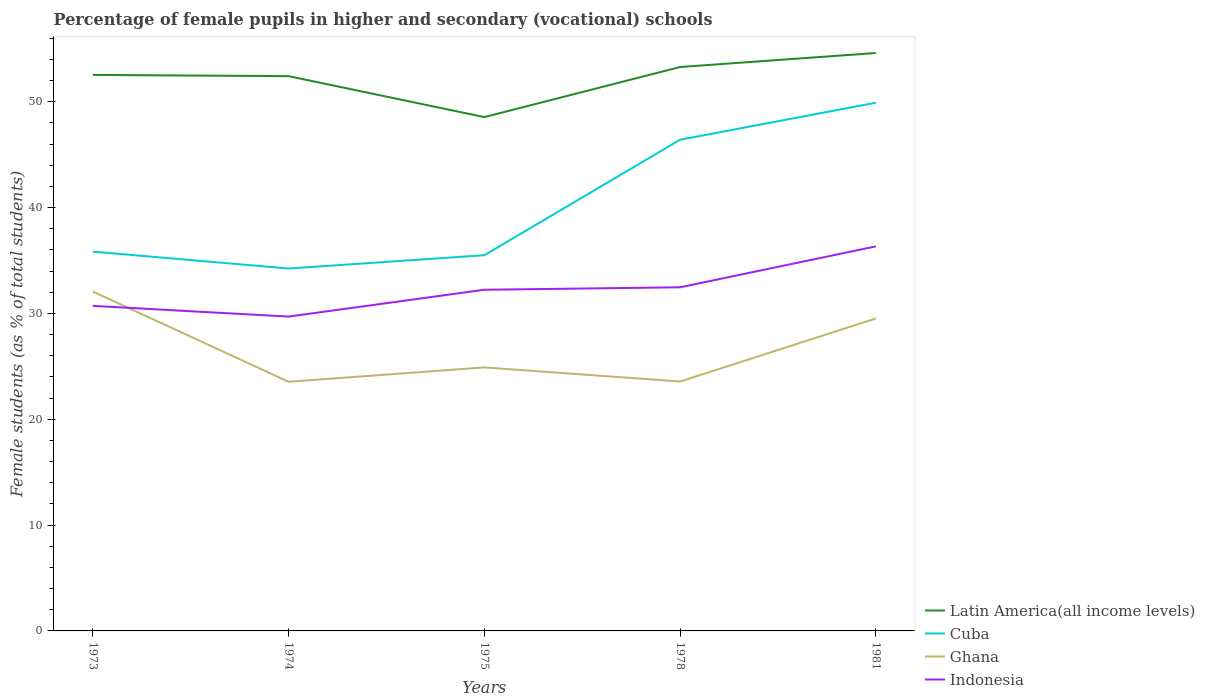How many different coloured lines are there?
Your answer should be very brief. 4. Does the line corresponding to Cuba intersect with the line corresponding to Indonesia?
Your answer should be very brief. No. Is the number of lines equal to the number of legend labels?
Ensure brevity in your answer.  Yes. Across all years, what is the maximum percentage of female pupils in higher and secondary schools in Indonesia?
Offer a very short reply. 29.7. In which year was the percentage of female pupils in higher and secondary schools in Ghana maximum?
Your answer should be compact. 1974. What is the total percentage of female pupils in higher and secondary schools in Ghana in the graph?
Ensure brevity in your answer.  -5.96. What is the difference between the highest and the second highest percentage of female pupils in higher and secondary schools in Latin America(all income levels)?
Make the answer very short. 6.06. What is the difference between the highest and the lowest percentage of female pupils in higher and secondary schools in Ghana?
Your response must be concise. 2. What is the difference between two consecutive major ticks on the Y-axis?
Provide a succinct answer. 10. Are the values on the major ticks of Y-axis written in scientific E-notation?
Ensure brevity in your answer.  No. Does the graph contain grids?
Offer a very short reply. No. How many legend labels are there?
Your answer should be very brief. 4. How are the legend labels stacked?
Make the answer very short. Vertical. What is the title of the graph?
Ensure brevity in your answer.  Percentage of female pupils in higher and secondary (vocational) schools. Does "Equatorial Guinea" appear as one of the legend labels in the graph?
Provide a short and direct response. No. What is the label or title of the X-axis?
Ensure brevity in your answer.  Years. What is the label or title of the Y-axis?
Offer a terse response. Female students (as % of total students). What is the Female students (as % of total students) of Latin America(all income levels) in 1973?
Keep it short and to the point. 52.54. What is the Female students (as % of total students) of Cuba in 1973?
Your answer should be very brief. 35.84. What is the Female students (as % of total students) in Ghana in 1973?
Offer a terse response. 32.07. What is the Female students (as % of total students) in Indonesia in 1973?
Make the answer very short. 30.72. What is the Female students (as % of total students) of Latin America(all income levels) in 1974?
Ensure brevity in your answer.  52.42. What is the Female students (as % of total students) of Cuba in 1974?
Your answer should be compact. 34.25. What is the Female students (as % of total students) in Ghana in 1974?
Offer a very short reply. 23.55. What is the Female students (as % of total students) of Indonesia in 1974?
Keep it short and to the point. 29.7. What is the Female students (as % of total students) of Latin America(all income levels) in 1975?
Your answer should be very brief. 48.56. What is the Female students (as % of total students) in Cuba in 1975?
Make the answer very short. 35.5. What is the Female students (as % of total students) of Ghana in 1975?
Ensure brevity in your answer.  24.9. What is the Female students (as % of total students) in Indonesia in 1975?
Give a very brief answer. 32.24. What is the Female students (as % of total students) in Latin America(all income levels) in 1978?
Keep it short and to the point. 53.29. What is the Female students (as % of total students) in Cuba in 1978?
Give a very brief answer. 46.42. What is the Female students (as % of total students) in Ghana in 1978?
Ensure brevity in your answer.  23.57. What is the Female students (as % of total students) of Indonesia in 1978?
Offer a terse response. 32.47. What is the Female students (as % of total students) of Latin America(all income levels) in 1981?
Keep it short and to the point. 54.61. What is the Female students (as % of total students) in Cuba in 1981?
Your answer should be very brief. 49.91. What is the Female students (as % of total students) of Ghana in 1981?
Give a very brief answer. 29.53. What is the Female students (as % of total students) in Indonesia in 1981?
Your answer should be compact. 36.34. Across all years, what is the maximum Female students (as % of total students) in Latin America(all income levels)?
Your answer should be compact. 54.61. Across all years, what is the maximum Female students (as % of total students) in Cuba?
Give a very brief answer. 49.91. Across all years, what is the maximum Female students (as % of total students) of Ghana?
Provide a short and direct response. 32.07. Across all years, what is the maximum Female students (as % of total students) in Indonesia?
Your response must be concise. 36.34. Across all years, what is the minimum Female students (as % of total students) in Latin America(all income levels)?
Provide a succinct answer. 48.56. Across all years, what is the minimum Female students (as % of total students) in Cuba?
Your answer should be very brief. 34.25. Across all years, what is the minimum Female students (as % of total students) in Ghana?
Offer a very short reply. 23.55. Across all years, what is the minimum Female students (as % of total students) in Indonesia?
Make the answer very short. 29.7. What is the total Female students (as % of total students) in Latin America(all income levels) in the graph?
Give a very brief answer. 261.42. What is the total Female students (as % of total students) in Cuba in the graph?
Your answer should be very brief. 201.92. What is the total Female students (as % of total students) of Ghana in the graph?
Provide a succinct answer. 133.61. What is the total Female students (as % of total students) of Indonesia in the graph?
Your response must be concise. 161.47. What is the difference between the Female students (as % of total students) of Latin America(all income levels) in 1973 and that in 1974?
Give a very brief answer. 0.12. What is the difference between the Female students (as % of total students) of Cuba in 1973 and that in 1974?
Your response must be concise. 1.6. What is the difference between the Female students (as % of total students) in Ghana in 1973 and that in 1974?
Your answer should be compact. 8.52. What is the difference between the Female students (as % of total students) in Indonesia in 1973 and that in 1974?
Your response must be concise. 1.01. What is the difference between the Female students (as % of total students) in Latin America(all income levels) in 1973 and that in 1975?
Your answer should be very brief. 3.99. What is the difference between the Female students (as % of total students) in Cuba in 1973 and that in 1975?
Provide a succinct answer. 0.34. What is the difference between the Female students (as % of total students) in Ghana in 1973 and that in 1975?
Offer a terse response. 7.17. What is the difference between the Female students (as % of total students) of Indonesia in 1973 and that in 1975?
Make the answer very short. -1.52. What is the difference between the Female students (as % of total students) in Latin America(all income levels) in 1973 and that in 1978?
Your response must be concise. -0.75. What is the difference between the Female students (as % of total students) in Cuba in 1973 and that in 1978?
Ensure brevity in your answer.  -10.57. What is the difference between the Female students (as % of total students) in Ghana in 1973 and that in 1978?
Ensure brevity in your answer.  8.5. What is the difference between the Female students (as % of total students) of Indonesia in 1973 and that in 1978?
Ensure brevity in your answer.  -1.75. What is the difference between the Female students (as % of total students) in Latin America(all income levels) in 1973 and that in 1981?
Provide a short and direct response. -2.07. What is the difference between the Female students (as % of total students) of Cuba in 1973 and that in 1981?
Make the answer very short. -14.07. What is the difference between the Female students (as % of total students) of Ghana in 1973 and that in 1981?
Provide a short and direct response. 2.54. What is the difference between the Female students (as % of total students) in Indonesia in 1973 and that in 1981?
Your answer should be very brief. -5.62. What is the difference between the Female students (as % of total students) in Latin America(all income levels) in 1974 and that in 1975?
Your answer should be very brief. 3.87. What is the difference between the Female students (as % of total students) in Cuba in 1974 and that in 1975?
Offer a very short reply. -1.26. What is the difference between the Female students (as % of total students) in Ghana in 1974 and that in 1975?
Provide a short and direct response. -1.36. What is the difference between the Female students (as % of total students) in Indonesia in 1974 and that in 1975?
Provide a succinct answer. -2.54. What is the difference between the Female students (as % of total students) in Latin America(all income levels) in 1974 and that in 1978?
Give a very brief answer. -0.86. What is the difference between the Female students (as % of total students) in Cuba in 1974 and that in 1978?
Make the answer very short. -12.17. What is the difference between the Female students (as % of total students) in Ghana in 1974 and that in 1978?
Make the answer very short. -0.02. What is the difference between the Female students (as % of total students) of Indonesia in 1974 and that in 1978?
Ensure brevity in your answer.  -2.77. What is the difference between the Female students (as % of total students) in Latin America(all income levels) in 1974 and that in 1981?
Your answer should be compact. -2.19. What is the difference between the Female students (as % of total students) in Cuba in 1974 and that in 1981?
Give a very brief answer. -15.67. What is the difference between the Female students (as % of total students) of Ghana in 1974 and that in 1981?
Make the answer very short. -5.98. What is the difference between the Female students (as % of total students) of Indonesia in 1974 and that in 1981?
Give a very brief answer. -6.64. What is the difference between the Female students (as % of total students) in Latin America(all income levels) in 1975 and that in 1978?
Offer a terse response. -4.73. What is the difference between the Female students (as % of total students) in Cuba in 1975 and that in 1978?
Your answer should be compact. -10.91. What is the difference between the Female students (as % of total students) of Ghana in 1975 and that in 1978?
Your response must be concise. 1.33. What is the difference between the Female students (as % of total students) in Indonesia in 1975 and that in 1978?
Keep it short and to the point. -0.23. What is the difference between the Female students (as % of total students) of Latin America(all income levels) in 1975 and that in 1981?
Ensure brevity in your answer.  -6.06. What is the difference between the Female students (as % of total students) in Cuba in 1975 and that in 1981?
Your answer should be compact. -14.41. What is the difference between the Female students (as % of total students) of Ghana in 1975 and that in 1981?
Offer a very short reply. -4.62. What is the difference between the Female students (as % of total students) of Indonesia in 1975 and that in 1981?
Make the answer very short. -4.1. What is the difference between the Female students (as % of total students) of Latin America(all income levels) in 1978 and that in 1981?
Your answer should be very brief. -1.32. What is the difference between the Female students (as % of total students) of Cuba in 1978 and that in 1981?
Your response must be concise. -3.5. What is the difference between the Female students (as % of total students) of Ghana in 1978 and that in 1981?
Your response must be concise. -5.96. What is the difference between the Female students (as % of total students) of Indonesia in 1978 and that in 1981?
Provide a short and direct response. -3.87. What is the difference between the Female students (as % of total students) of Latin America(all income levels) in 1973 and the Female students (as % of total students) of Cuba in 1974?
Your answer should be compact. 18.3. What is the difference between the Female students (as % of total students) of Latin America(all income levels) in 1973 and the Female students (as % of total students) of Ghana in 1974?
Provide a succinct answer. 29. What is the difference between the Female students (as % of total students) in Latin America(all income levels) in 1973 and the Female students (as % of total students) in Indonesia in 1974?
Provide a short and direct response. 22.84. What is the difference between the Female students (as % of total students) in Cuba in 1973 and the Female students (as % of total students) in Ghana in 1974?
Offer a very short reply. 12.3. What is the difference between the Female students (as % of total students) of Cuba in 1973 and the Female students (as % of total students) of Indonesia in 1974?
Keep it short and to the point. 6.14. What is the difference between the Female students (as % of total students) in Ghana in 1973 and the Female students (as % of total students) in Indonesia in 1974?
Your answer should be compact. 2.36. What is the difference between the Female students (as % of total students) of Latin America(all income levels) in 1973 and the Female students (as % of total students) of Cuba in 1975?
Offer a terse response. 17.04. What is the difference between the Female students (as % of total students) of Latin America(all income levels) in 1973 and the Female students (as % of total students) of Ghana in 1975?
Offer a terse response. 27.64. What is the difference between the Female students (as % of total students) of Latin America(all income levels) in 1973 and the Female students (as % of total students) of Indonesia in 1975?
Make the answer very short. 20.3. What is the difference between the Female students (as % of total students) of Cuba in 1973 and the Female students (as % of total students) of Ghana in 1975?
Your answer should be very brief. 10.94. What is the difference between the Female students (as % of total students) of Cuba in 1973 and the Female students (as % of total students) of Indonesia in 1975?
Make the answer very short. 3.6. What is the difference between the Female students (as % of total students) of Ghana in 1973 and the Female students (as % of total students) of Indonesia in 1975?
Provide a succinct answer. -0.17. What is the difference between the Female students (as % of total students) in Latin America(all income levels) in 1973 and the Female students (as % of total students) in Cuba in 1978?
Provide a succinct answer. 6.13. What is the difference between the Female students (as % of total students) in Latin America(all income levels) in 1973 and the Female students (as % of total students) in Ghana in 1978?
Offer a very short reply. 28.97. What is the difference between the Female students (as % of total students) in Latin America(all income levels) in 1973 and the Female students (as % of total students) in Indonesia in 1978?
Keep it short and to the point. 20.07. What is the difference between the Female students (as % of total students) in Cuba in 1973 and the Female students (as % of total students) in Ghana in 1978?
Offer a very short reply. 12.27. What is the difference between the Female students (as % of total students) of Cuba in 1973 and the Female students (as % of total students) of Indonesia in 1978?
Give a very brief answer. 3.37. What is the difference between the Female students (as % of total students) of Ghana in 1973 and the Female students (as % of total students) of Indonesia in 1978?
Ensure brevity in your answer.  -0.4. What is the difference between the Female students (as % of total students) in Latin America(all income levels) in 1973 and the Female students (as % of total students) in Cuba in 1981?
Offer a terse response. 2.63. What is the difference between the Female students (as % of total students) of Latin America(all income levels) in 1973 and the Female students (as % of total students) of Ghana in 1981?
Make the answer very short. 23.02. What is the difference between the Female students (as % of total students) in Latin America(all income levels) in 1973 and the Female students (as % of total students) in Indonesia in 1981?
Provide a succinct answer. 16.2. What is the difference between the Female students (as % of total students) in Cuba in 1973 and the Female students (as % of total students) in Ghana in 1981?
Provide a succinct answer. 6.32. What is the difference between the Female students (as % of total students) of Cuba in 1973 and the Female students (as % of total students) of Indonesia in 1981?
Your answer should be very brief. -0.5. What is the difference between the Female students (as % of total students) in Ghana in 1973 and the Female students (as % of total students) in Indonesia in 1981?
Keep it short and to the point. -4.27. What is the difference between the Female students (as % of total students) of Latin America(all income levels) in 1974 and the Female students (as % of total students) of Cuba in 1975?
Provide a short and direct response. 16.92. What is the difference between the Female students (as % of total students) of Latin America(all income levels) in 1974 and the Female students (as % of total students) of Ghana in 1975?
Give a very brief answer. 27.52. What is the difference between the Female students (as % of total students) in Latin America(all income levels) in 1974 and the Female students (as % of total students) in Indonesia in 1975?
Ensure brevity in your answer.  20.18. What is the difference between the Female students (as % of total students) of Cuba in 1974 and the Female students (as % of total students) of Ghana in 1975?
Your answer should be compact. 9.34. What is the difference between the Female students (as % of total students) of Cuba in 1974 and the Female students (as % of total students) of Indonesia in 1975?
Keep it short and to the point. 2.01. What is the difference between the Female students (as % of total students) in Ghana in 1974 and the Female students (as % of total students) in Indonesia in 1975?
Make the answer very short. -8.7. What is the difference between the Female students (as % of total students) in Latin America(all income levels) in 1974 and the Female students (as % of total students) in Cuba in 1978?
Your answer should be compact. 6.01. What is the difference between the Female students (as % of total students) of Latin America(all income levels) in 1974 and the Female students (as % of total students) of Ghana in 1978?
Offer a very short reply. 28.86. What is the difference between the Female students (as % of total students) in Latin America(all income levels) in 1974 and the Female students (as % of total students) in Indonesia in 1978?
Offer a very short reply. 19.95. What is the difference between the Female students (as % of total students) of Cuba in 1974 and the Female students (as % of total students) of Ghana in 1978?
Your answer should be compact. 10.68. What is the difference between the Female students (as % of total students) in Cuba in 1974 and the Female students (as % of total students) in Indonesia in 1978?
Ensure brevity in your answer.  1.77. What is the difference between the Female students (as % of total students) of Ghana in 1974 and the Female students (as % of total students) of Indonesia in 1978?
Keep it short and to the point. -8.93. What is the difference between the Female students (as % of total students) in Latin America(all income levels) in 1974 and the Female students (as % of total students) in Cuba in 1981?
Ensure brevity in your answer.  2.51. What is the difference between the Female students (as % of total students) in Latin America(all income levels) in 1974 and the Female students (as % of total students) in Ghana in 1981?
Offer a very short reply. 22.9. What is the difference between the Female students (as % of total students) of Latin America(all income levels) in 1974 and the Female students (as % of total students) of Indonesia in 1981?
Your response must be concise. 16.09. What is the difference between the Female students (as % of total students) of Cuba in 1974 and the Female students (as % of total students) of Ghana in 1981?
Your response must be concise. 4.72. What is the difference between the Female students (as % of total students) in Cuba in 1974 and the Female students (as % of total students) in Indonesia in 1981?
Your response must be concise. -2.09. What is the difference between the Female students (as % of total students) of Ghana in 1974 and the Female students (as % of total students) of Indonesia in 1981?
Ensure brevity in your answer.  -12.79. What is the difference between the Female students (as % of total students) of Latin America(all income levels) in 1975 and the Female students (as % of total students) of Cuba in 1978?
Offer a very short reply. 2.14. What is the difference between the Female students (as % of total students) in Latin America(all income levels) in 1975 and the Female students (as % of total students) in Ghana in 1978?
Give a very brief answer. 24.99. What is the difference between the Female students (as % of total students) in Latin America(all income levels) in 1975 and the Female students (as % of total students) in Indonesia in 1978?
Offer a very short reply. 16.08. What is the difference between the Female students (as % of total students) of Cuba in 1975 and the Female students (as % of total students) of Ghana in 1978?
Offer a terse response. 11.94. What is the difference between the Female students (as % of total students) in Cuba in 1975 and the Female students (as % of total students) in Indonesia in 1978?
Offer a very short reply. 3.03. What is the difference between the Female students (as % of total students) in Ghana in 1975 and the Female students (as % of total students) in Indonesia in 1978?
Offer a terse response. -7.57. What is the difference between the Female students (as % of total students) in Latin America(all income levels) in 1975 and the Female students (as % of total students) in Cuba in 1981?
Your response must be concise. -1.36. What is the difference between the Female students (as % of total students) of Latin America(all income levels) in 1975 and the Female students (as % of total students) of Ghana in 1981?
Give a very brief answer. 19.03. What is the difference between the Female students (as % of total students) in Latin America(all income levels) in 1975 and the Female students (as % of total students) in Indonesia in 1981?
Provide a short and direct response. 12.22. What is the difference between the Female students (as % of total students) of Cuba in 1975 and the Female students (as % of total students) of Ghana in 1981?
Give a very brief answer. 5.98. What is the difference between the Female students (as % of total students) in Cuba in 1975 and the Female students (as % of total students) in Indonesia in 1981?
Provide a short and direct response. -0.84. What is the difference between the Female students (as % of total students) of Ghana in 1975 and the Female students (as % of total students) of Indonesia in 1981?
Provide a succinct answer. -11.44. What is the difference between the Female students (as % of total students) of Latin America(all income levels) in 1978 and the Female students (as % of total students) of Cuba in 1981?
Keep it short and to the point. 3.37. What is the difference between the Female students (as % of total students) of Latin America(all income levels) in 1978 and the Female students (as % of total students) of Ghana in 1981?
Give a very brief answer. 23.76. What is the difference between the Female students (as % of total students) of Latin America(all income levels) in 1978 and the Female students (as % of total students) of Indonesia in 1981?
Provide a short and direct response. 16.95. What is the difference between the Female students (as % of total students) in Cuba in 1978 and the Female students (as % of total students) in Ghana in 1981?
Offer a very short reply. 16.89. What is the difference between the Female students (as % of total students) in Cuba in 1978 and the Female students (as % of total students) in Indonesia in 1981?
Provide a succinct answer. 10.08. What is the difference between the Female students (as % of total students) in Ghana in 1978 and the Female students (as % of total students) in Indonesia in 1981?
Ensure brevity in your answer.  -12.77. What is the average Female students (as % of total students) in Latin America(all income levels) per year?
Give a very brief answer. 52.28. What is the average Female students (as % of total students) of Cuba per year?
Provide a short and direct response. 40.38. What is the average Female students (as % of total students) in Ghana per year?
Provide a succinct answer. 26.72. What is the average Female students (as % of total students) of Indonesia per year?
Your answer should be very brief. 32.29. In the year 1973, what is the difference between the Female students (as % of total students) of Latin America(all income levels) and Female students (as % of total students) of Cuba?
Your response must be concise. 16.7. In the year 1973, what is the difference between the Female students (as % of total students) in Latin America(all income levels) and Female students (as % of total students) in Ghana?
Your answer should be very brief. 20.47. In the year 1973, what is the difference between the Female students (as % of total students) in Latin America(all income levels) and Female students (as % of total students) in Indonesia?
Your answer should be compact. 21.82. In the year 1973, what is the difference between the Female students (as % of total students) in Cuba and Female students (as % of total students) in Ghana?
Keep it short and to the point. 3.77. In the year 1973, what is the difference between the Female students (as % of total students) in Cuba and Female students (as % of total students) in Indonesia?
Your response must be concise. 5.12. In the year 1973, what is the difference between the Female students (as % of total students) in Ghana and Female students (as % of total students) in Indonesia?
Keep it short and to the point. 1.35. In the year 1974, what is the difference between the Female students (as % of total students) of Latin America(all income levels) and Female students (as % of total students) of Cuba?
Provide a short and direct response. 18.18. In the year 1974, what is the difference between the Female students (as % of total students) in Latin America(all income levels) and Female students (as % of total students) in Ghana?
Make the answer very short. 28.88. In the year 1974, what is the difference between the Female students (as % of total students) in Latin America(all income levels) and Female students (as % of total students) in Indonesia?
Provide a succinct answer. 22.72. In the year 1974, what is the difference between the Female students (as % of total students) of Cuba and Female students (as % of total students) of Ghana?
Keep it short and to the point. 10.7. In the year 1974, what is the difference between the Female students (as % of total students) of Cuba and Female students (as % of total students) of Indonesia?
Ensure brevity in your answer.  4.54. In the year 1974, what is the difference between the Female students (as % of total students) in Ghana and Female students (as % of total students) in Indonesia?
Provide a succinct answer. -6.16. In the year 1975, what is the difference between the Female students (as % of total students) in Latin America(all income levels) and Female students (as % of total students) in Cuba?
Give a very brief answer. 13.05. In the year 1975, what is the difference between the Female students (as % of total students) of Latin America(all income levels) and Female students (as % of total students) of Ghana?
Offer a terse response. 23.65. In the year 1975, what is the difference between the Female students (as % of total students) of Latin America(all income levels) and Female students (as % of total students) of Indonesia?
Ensure brevity in your answer.  16.31. In the year 1975, what is the difference between the Female students (as % of total students) in Cuba and Female students (as % of total students) in Ghana?
Make the answer very short. 10.6. In the year 1975, what is the difference between the Female students (as % of total students) of Cuba and Female students (as % of total students) of Indonesia?
Ensure brevity in your answer.  3.26. In the year 1975, what is the difference between the Female students (as % of total students) of Ghana and Female students (as % of total students) of Indonesia?
Offer a terse response. -7.34. In the year 1978, what is the difference between the Female students (as % of total students) in Latin America(all income levels) and Female students (as % of total students) in Cuba?
Keep it short and to the point. 6.87. In the year 1978, what is the difference between the Female students (as % of total students) in Latin America(all income levels) and Female students (as % of total students) in Ghana?
Your answer should be very brief. 29.72. In the year 1978, what is the difference between the Female students (as % of total students) of Latin America(all income levels) and Female students (as % of total students) of Indonesia?
Ensure brevity in your answer.  20.82. In the year 1978, what is the difference between the Female students (as % of total students) in Cuba and Female students (as % of total students) in Ghana?
Give a very brief answer. 22.85. In the year 1978, what is the difference between the Female students (as % of total students) of Cuba and Female students (as % of total students) of Indonesia?
Your response must be concise. 13.94. In the year 1978, what is the difference between the Female students (as % of total students) of Ghana and Female students (as % of total students) of Indonesia?
Keep it short and to the point. -8.9. In the year 1981, what is the difference between the Female students (as % of total students) in Latin America(all income levels) and Female students (as % of total students) in Cuba?
Ensure brevity in your answer.  4.7. In the year 1981, what is the difference between the Female students (as % of total students) in Latin America(all income levels) and Female students (as % of total students) in Ghana?
Ensure brevity in your answer.  25.09. In the year 1981, what is the difference between the Female students (as % of total students) of Latin America(all income levels) and Female students (as % of total students) of Indonesia?
Provide a short and direct response. 18.27. In the year 1981, what is the difference between the Female students (as % of total students) of Cuba and Female students (as % of total students) of Ghana?
Ensure brevity in your answer.  20.39. In the year 1981, what is the difference between the Female students (as % of total students) of Cuba and Female students (as % of total students) of Indonesia?
Provide a succinct answer. 13.57. In the year 1981, what is the difference between the Female students (as % of total students) in Ghana and Female students (as % of total students) in Indonesia?
Keep it short and to the point. -6.81. What is the ratio of the Female students (as % of total students) in Latin America(all income levels) in 1973 to that in 1974?
Give a very brief answer. 1. What is the ratio of the Female students (as % of total students) in Cuba in 1973 to that in 1974?
Ensure brevity in your answer.  1.05. What is the ratio of the Female students (as % of total students) in Ghana in 1973 to that in 1974?
Provide a short and direct response. 1.36. What is the ratio of the Female students (as % of total students) in Indonesia in 1973 to that in 1974?
Your answer should be compact. 1.03. What is the ratio of the Female students (as % of total students) of Latin America(all income levels) in 1973 to that in 1975?
Ensure brevity in your answer.  1.08. What is the ratio of the Female students (as % of total students) in Cuba in 1973 to that in 1975?
Your answer should be compact. 1.01. What is the ratio of the Female students (as % of total students) of Ghana in 1973 to that in 1975?
Offer a very short reply. 1.29. What is the ratio of the Female students (as % of total students) in Indonesia in 1973 to that in 1975?
Provide a short and direct response. 0.95. What is the ratio of the Female students (as % of total students) in Latin America(all income levels) in 1973 to that in 1978?
Offer a very short reply. 0.99. What is the ratio of the Female students (as % of total students) in Cuba in 1973 to that in 1978?
Ensure brevity in your answer.  0.77. What is the ratio of the Female students (as % of total students) of Ghana in 1973 to that in 1978?
Ensure brevity in your answer.  1.36. What is the ratio of the Female students (as % of total students) of Indonesia in 1973 to that in 1978?
Offer a very short reply. 0.95. What is the ratio of the Female students (as % of total students) of Latin America(all income levels) in 1973 to that in 1981?
Offer a terse response. 0.96. What is the ratio of the Female students (as % of total students) in Cuba in 1973 to that in 1981?
Provide a short and direct response. 0.72. What is the ratio of the Female students (as % of total students) of Ghana in 1973 to that in 1981?
Make the answer very short. 1.09. What is the ratio of the Female students (as % of total students) of Indonesia in 1973 to that in 1981?
Your response must be concise. 0.85. What is the ratio of the Female students (as % of total students) of Latin America(all income levels) in 1974 to that in 1975?
Keep it short and to the point. 1.08. What is the ratio of the Female students (as % of total students) in Cuba in 1974 to that in 1975?
Offer a very short reply. 0.96. What is the ratio of the Female students (as % of total students) in Ghana in 1974 to that in 1975?
Your answer should be very brief. 0.95. What is the ratio of the Female students (as % of total students) in Indonesia in 1974 to that in 1975?
Your answer should be very brief. 0.92. What is the ratio of the Female students (as % of total students) in Latin America(all income levels) in 1974 to that in 1978?
Your answer should be very brief. 0.98. What is the ratio of the Female students (as % of total students) of Cuba in 1974 to that in 1978?
Keep it short and to the point. 0.74. What is the ratio of the Female students (as % of total students) in Indonesia in 1974 to that in 1978?
Make the answer very short. 0.91. What is the ratio of the Female students (as % of total students) in Cuba in 1974 to that in 1981?
Your answer should be very brief. 0.69. What is the ratio of the Female students (as % of total students) in Ghana in 1974 to that in 1981?
Offer a very short reply. 0.8. What is the ratio of the Female students (as % of total students) of Indonesia in 1974 to that in 1981?
Provide a succinct answer. 0.82. What is the ratio of the Female students (as % of total students) of Latin America(all income levels) in 1975 to that in 1978?
Your answer should be very brief. 0.91. What is the ratio of the Female students (as % of total students) in Cuba in 1975 to that in 1978?
Provide a succinct answer. 0.76. What is the ratio of the Female students (as % of total students) of Ghana in 1975 to that in 1978?
Offer a very short reply. 1.06. What is the ratio of the Female students (as % of total students) in Indonesia in 1975 to that in 1978?
Your response must be concise. 0.99. What is the ratio of the Female students (as % of total students) of Latin America(all income levels) in 1975 to that in 1981?
Provide a succinct answer. 0.89. What is the ratio of the Female students (as % of total students) in Cuba in 1975 to that in 1981?
Your response must be concise. 0.71. What is the ratio of the Female students (as % of total students) of Ghana in 1975 to that in 1981?
Offer a very short reply. 0.84. What is the ratio of the Female students (as % of total students) of Indonesia in 1975 to that in 1981?
Your answer should be compact. 0.89. What is the ratio of the Female students (as % of total students) in Latin America(all income levels) in 1978 to that in 1981?
Your answer should be very brief. 0.98. What is the ratio of the Female students (as % of total students) in Cuba in 1978 to that in 1981?
Your response must be concise. 0.93. What is the ratio of the Female students (as % of total students) of Ghana in 1978 to that in 1981?
Offer a very short reply. 0.8. What is the ratio of the Female students (as % of total students) in Indonesia in 1978 to that in 1981?
Your response must be concise. 0.89. What is the difference between the highest and the second highest Female students (as % of total students) in Latin America(all income levels)?
Ensure brevity in your answer.  1.32. What is the difference between the highest and the second highest Female students (as % of total students) of Cuba?
Your answer should be very brief. 3.5. What is the difference between the highest and the second highest Female students (as % of total students) of Ghana?
Offer a very short reply. 2.54. What is the difference between the highest and the second highest Female students (as % of total students) of Indonesia?
Give a very brief answer. 3.87. What is the difference between the highest and the lowest Female students (as % of total students) in Latin America(all income levels)?
Make the answer very short. 6.06. What is the difference between the highest and the lowest Female students (as % of total students) in Cuba?
Provide a succinct answer. 15.67. What is the difference between the highest and the lowest Female students (as % of total students) in Ghana?
Offer a very short reply. 8.52. What is the difference between the highest and the lowest Female students (as % of total students) in Indonesia?
Your answer should be compact. 6.64. 